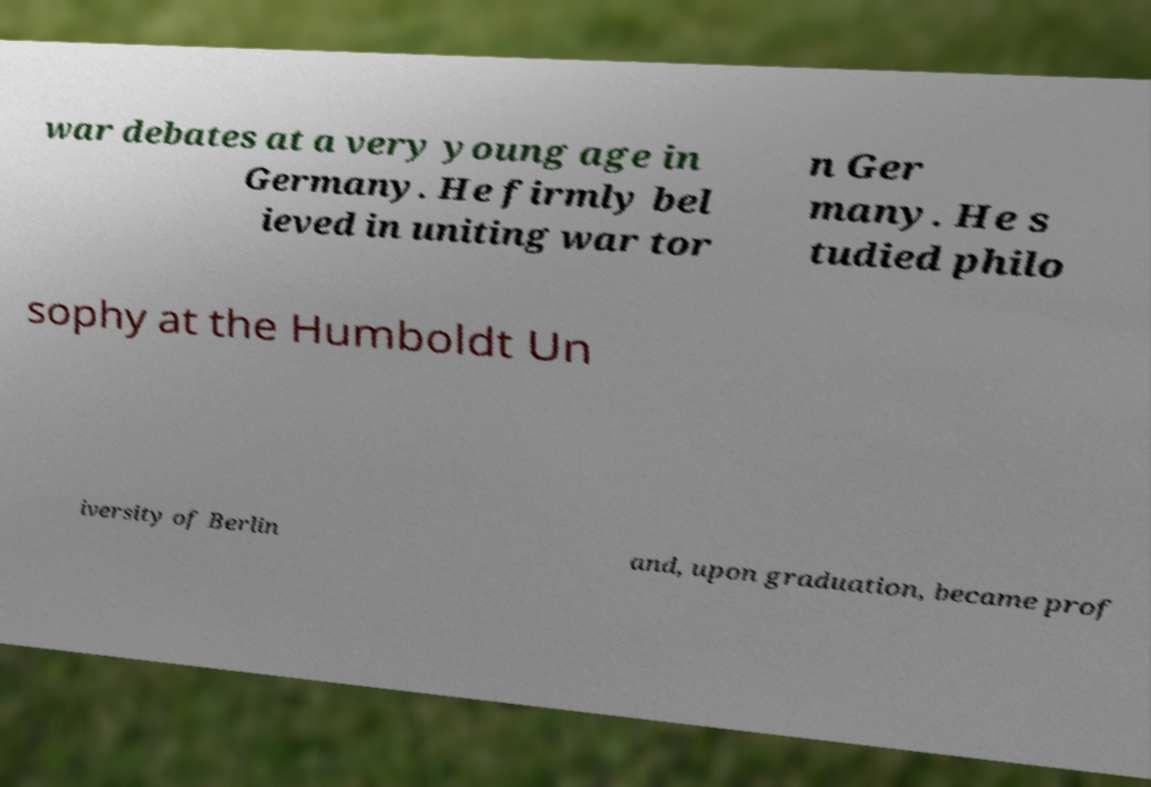Can you read and provide the text displayed in the image?This photo seems to have some interesting text. Can you extract and type it out for me? war debates at a very young age in Germany. He firmly bel ieved in uniting war tor n Ger many. He s tudied philo sophy at the Humboldt Un iversity of Berlin and, upon graduation, became prof 